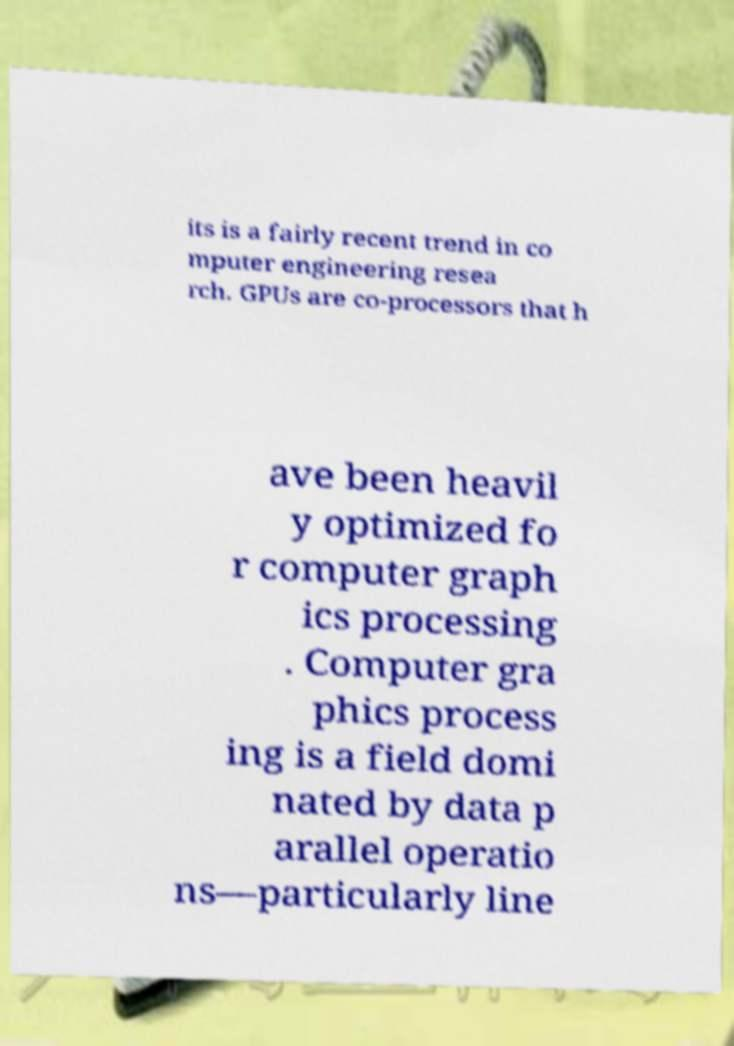There's text embedded in this image that I need extracted. Can you transcribe it verbatim? its is a fairly recent trend in co mputer engineering resea rch. GPUs are co-processors that h ave been heavil y optimized fo r computer graph ics processing . Computer gra phics process ing is a field domi nated by data p arallel operatio ns—particularly line 